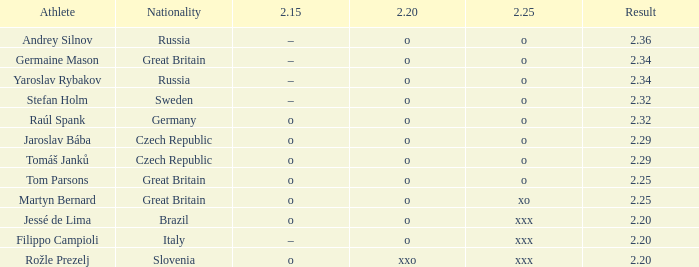Which athlete from Brazil has 2.20 O and 2.25 of XXX? Jessé de Lima. 